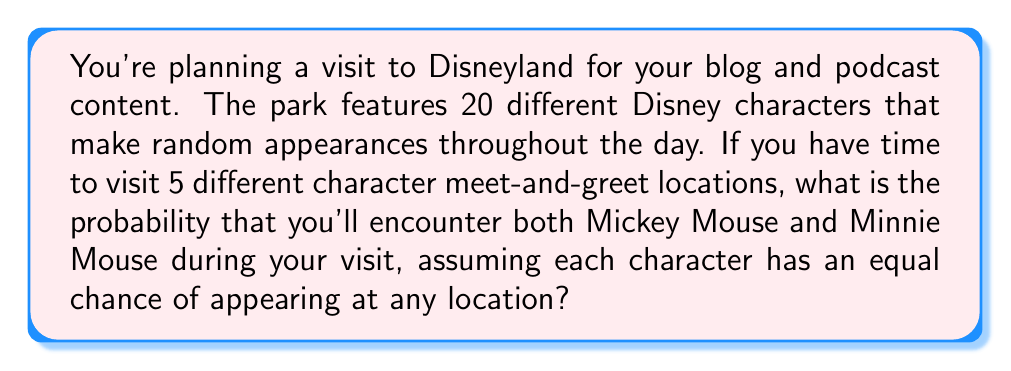Help me with this question. Let's approach this step-by-step:

1) First, we need to calculate the probability of meeting Mickey Mouse and Minnie Mouse in 5 attempts.

2) This is equivalent to the probability of not failing to meet both of them in 5 attempts.

3) The probability of not meeting Mickey at a single location is $\frac{19}{20}$, and the same for Minnie.

4) The probability of not meeting either Mickey or Minnie at a single location is:

   $$\frac{18}{20} = \frac{9}{10}$$

5) For all 5 locations, the probability of not meeting either of them is:

   $$\left(\frac{9}{10}\right)^5 = \frac{59049}{100000}$$

6) Therefore, the probability of meeting at least one of them is:

   $$1 - \frac{59049}{100000} = \frac{40951}{100000}$$

7) However, we want the probability of meeting both. This is equal to the probability of meeting at least one of them minus the probability of meeting exactly one of them.

8) The probability of meeting exactly Mickey in 5 attempts is:

   $$\binom{5}{1} \cdot \frac{1}{20} \cdot \left(\frac{19}{20}\right)^4 = \frac{3125}{160000}$$

   The same applies for Minnie.

9) So, the probability of meeting exactly one of them is:

   $$2 \cdot \frac{3125}{160000} = \frac{3125}{80000}$$

10) Finally, the probability of meeting both Mickey and Minnie is:

    $$\frac{40951}{100000} - \frac{3125}{80000} = \frac{6515}{16000} = 0.4071875$$
Answer: $\frac{6515}{16000}$ or approximately 0.4072 